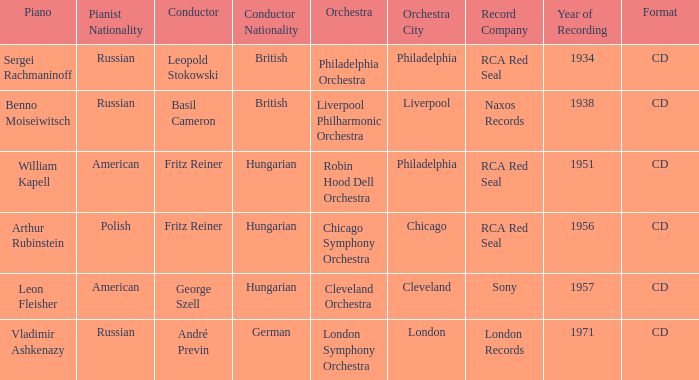Which orchestra has a recording year of 1951? Robin Hood Dell Orchestra. 